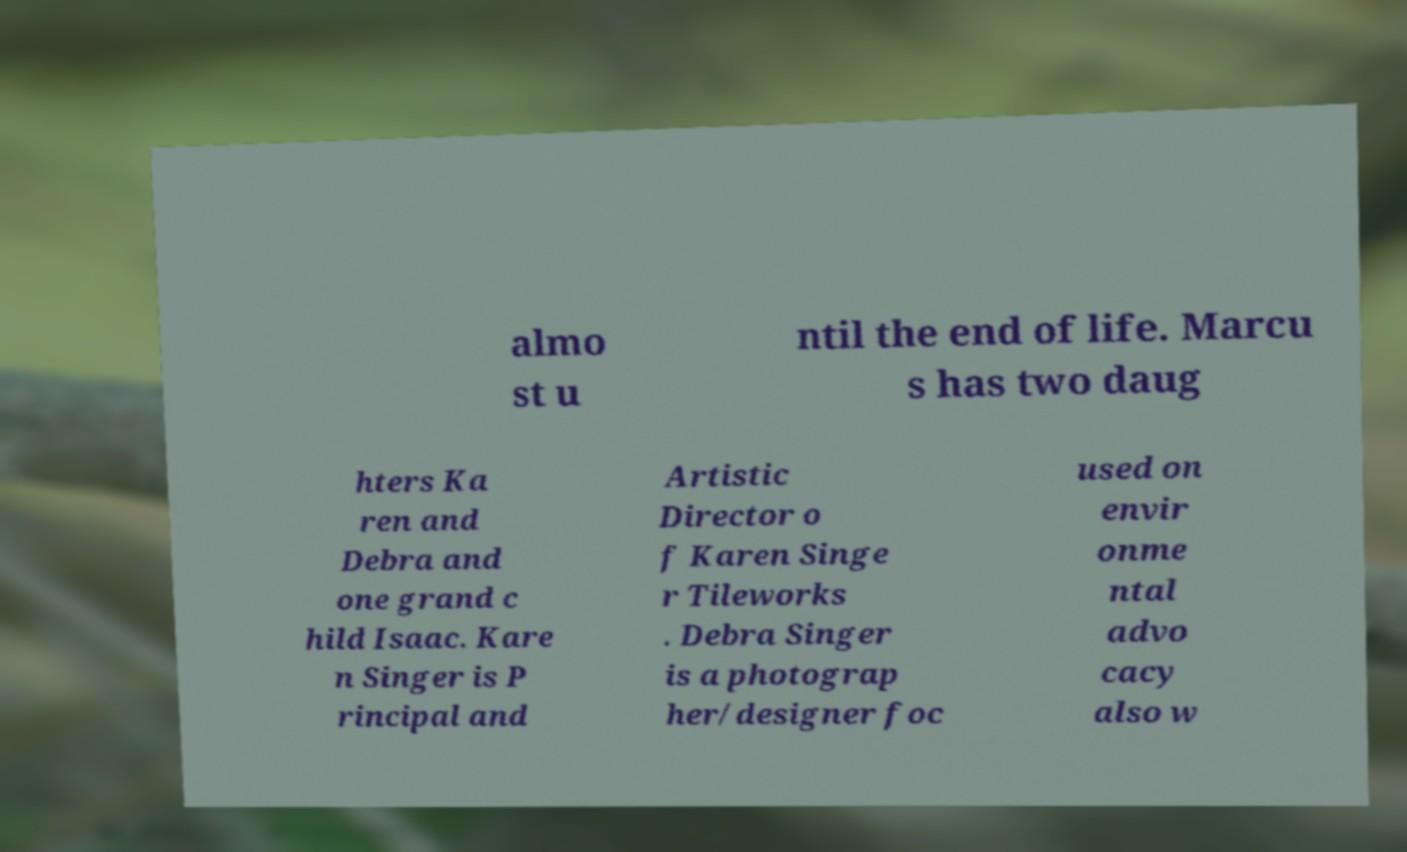For documentation purposes, I need the text within this image transcribed. Could you provide that? almo st u ntil the end of life. Marcu s has two daug hters Ka ren and Debra and one grand c hild Isaac. Kare n Singer is P rincipal and Artistic Director o f Karen Singe r Tileworks . Debra Singer is a photograp her/designer foc used on envir onme ntal advo cacy also w 